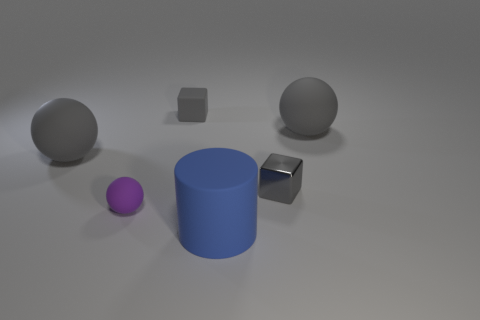Subtract all purple spheres. How many spheres are left? 2 Add 3 tiny gray shiny things. How many objects exist? 9 Subtract all purple spheres. How many spheres are left? 2 Subtract all yellow cylinders. How many gray balls are left? 2 Subtract 1 cubes. How many cubes are left? 1 Subtract all cylinders. How many objects are left? 5 Add 1 large cylinders. How many large cylinders exist? 2 Subtract 0 cyan blocks. How many objects are left? 6 Subtract all cyan balls. Subtract all cyan blocks. How many balls are left? 3 Subtract all yellow metallic cubes. Subtract all purple objects. How many objects are left? 5 